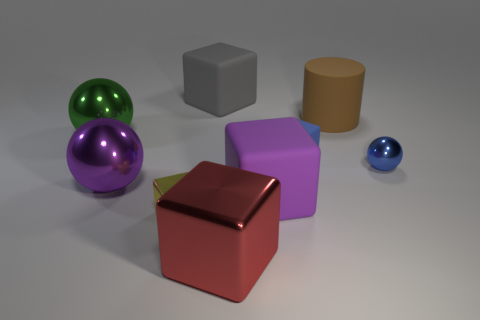There is a green metallic thing; are there any brown rubber objects in front of it?
Give a very brief answer. No. What number of green objects are behind the large metallic object in front of the small yellow thing?
Your answer should be compact. 1. There is a sphere that is the same size as the blue rubber thing; what is its material?
Your answer should be compact. Metal. How many other objects are there of the same material as the purple block?
Give a very brief answer. 3. How many things are behind the purple sphere?
Keep it short and to the point. 5. What number of blocks are large red metal objects or gray rubber things?
Ensure brevity in your answer.  2. There is a rubber thing that is on the left side of the blue cube and behind the tiny blue matte cube; what size is it?
Make the answer very short. Large. How many other objects are there of the same color as the cylinder?
Your answer should be compact. 0. Is the material of the large brown thing the same as the thing to the right of the big rubber cylinder?
Your answer should be very brief. No. What number of things are either blocks on the left side of the gray object or large rubber things?
Keep it short and to the point. 4. 